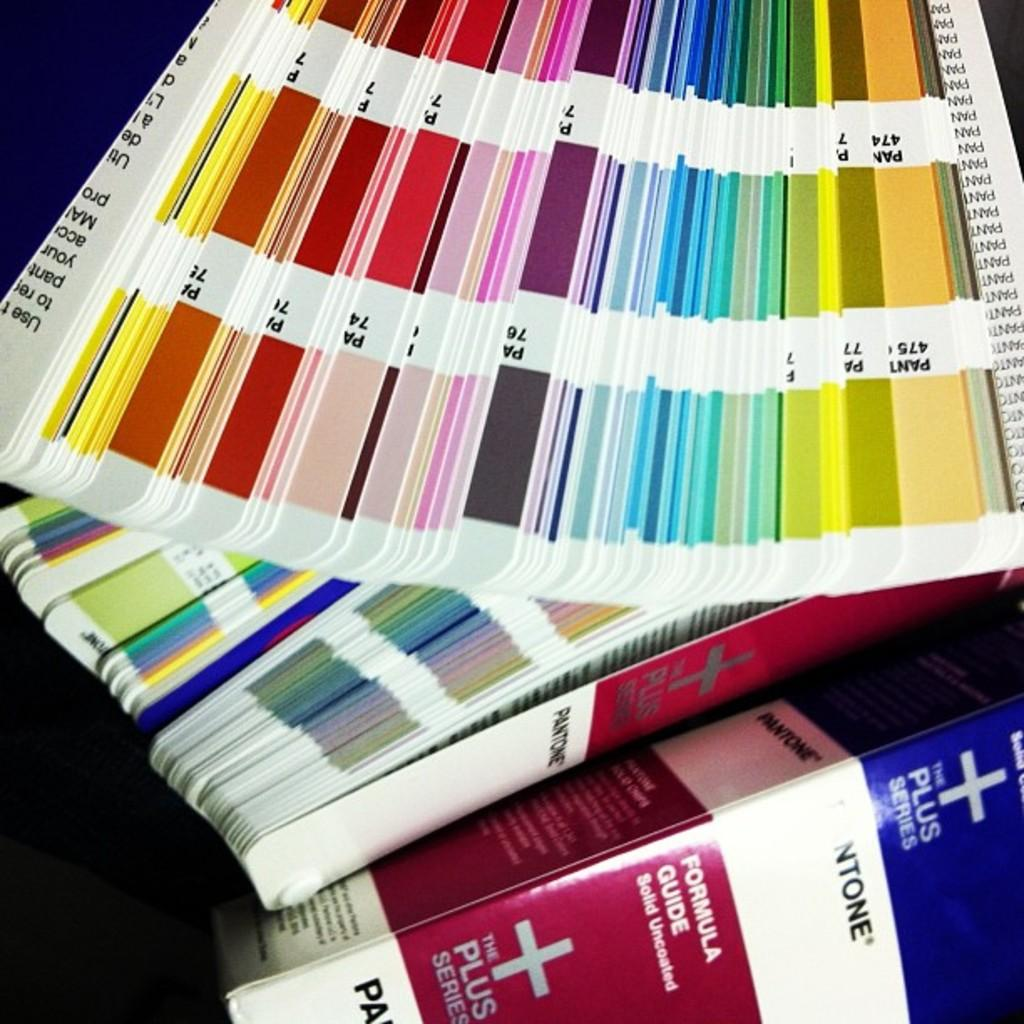<image>
Give a short and clear explanation of the subsequent image. Near paint samples is a box labeled the plus series. 